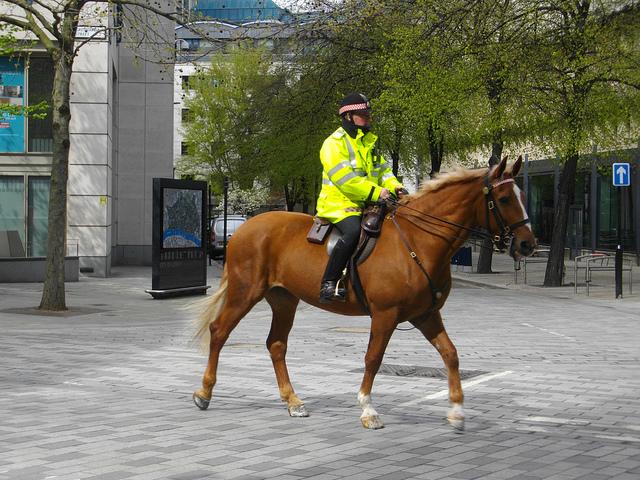What is this man's occupation?
Write a very short answer. Police officer. Is this horse galloping?
Concise answer only. No. Is this in from of a building?
Quick response, please. Yes. Are there any cabs in the street?
Keep it brief. No. 